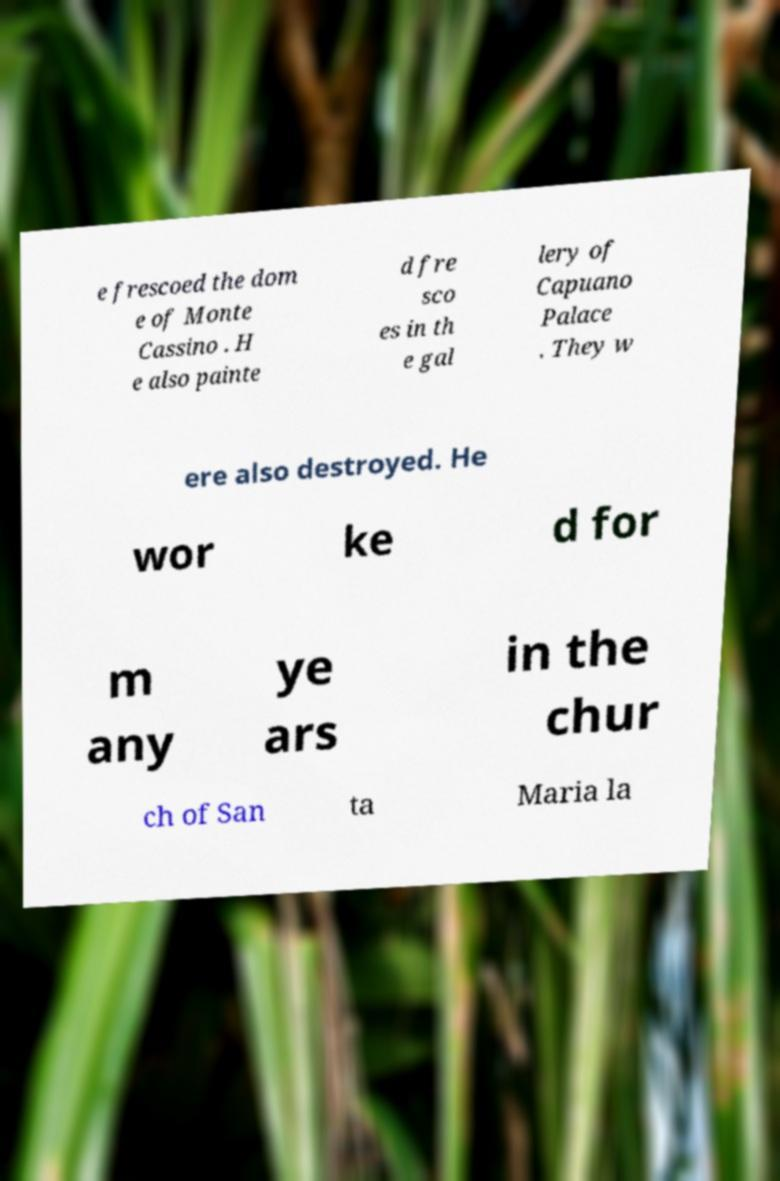Could you assist in decoding the text presented in this image and type it out clearly? e frescoed the dom e of Monte Cassino . H e also painte d fre sco es in th e gal lery of Capuano Palace . They w ere also destroyed. He wor ke d for m any ye ars in the chur ch of San ta Maria la 